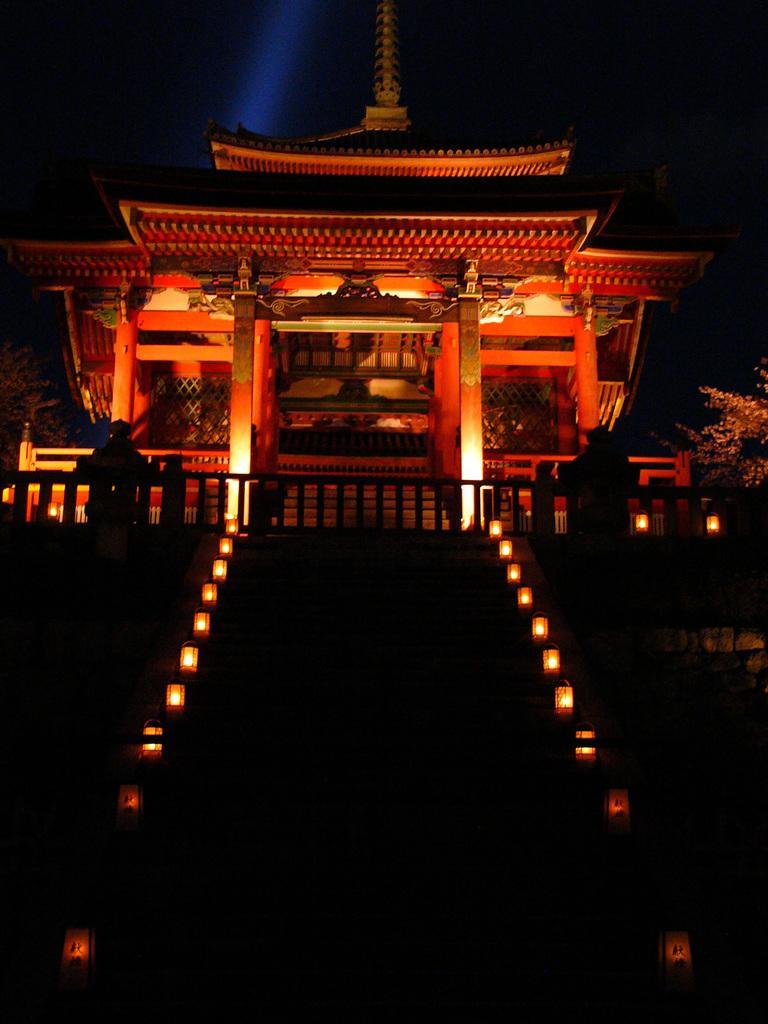Can you describe this image briefly? In this image in the center there is one building and some lights, at the bottom there are some stairs and lights. On the right side and left side there are plants. 